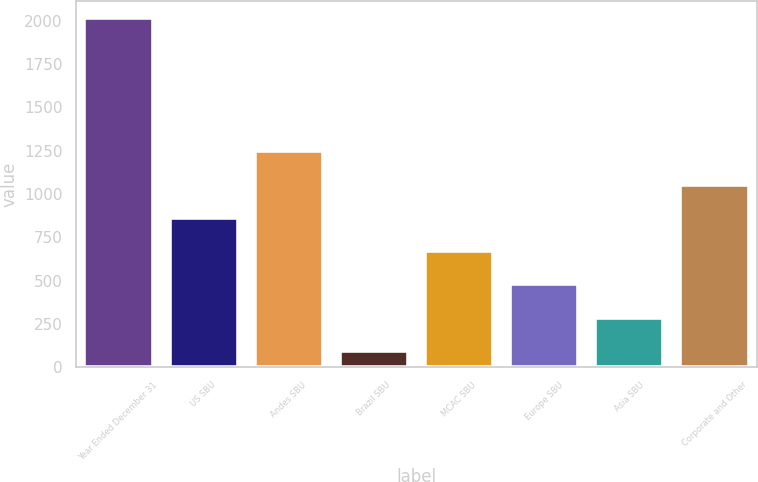Convert chart to OTSL. <chart><loc_0><loc_0><loc_500><loc_500><bar_chart><fcel>Year Ended December 31<fcel>US SBU<fcel>Andes SBU<fcel>Brazil SBU<fcel>MCAC SBU<fcel>Europe SBU<fcel>Asia SBU<fcel>Corporate and Other<nl><fcel>2015<fcel>861.8<fcel>1246.2<fcel>93<fcel>669.6<fcel>477.4<fcel>285.2<fcel>1054<nl></chart> 